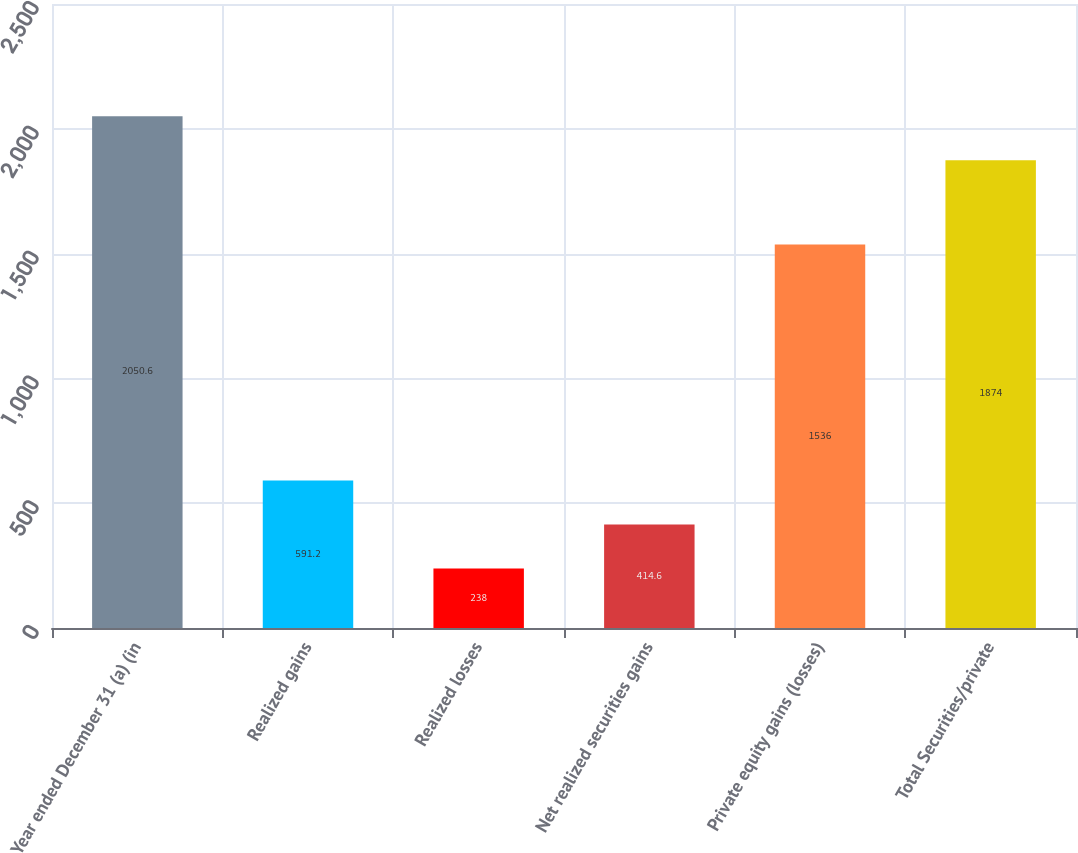Convert chart to OTSL. <chart><loc_0><loc_0><loc_500><loc_500><bar_chart><fcel>Year ended December 31 (a) (in<fcel>Realized gains<fcel>Realized losses<fcel>Net realized securities gains<fcel>Private equity gains (losses)<fcel>Total Securities/private<nl><fcel>2050.6<fcel>591.2<fcel>238<fcel>414.6<fcel>1536<fcel>1874<nl></chart> 